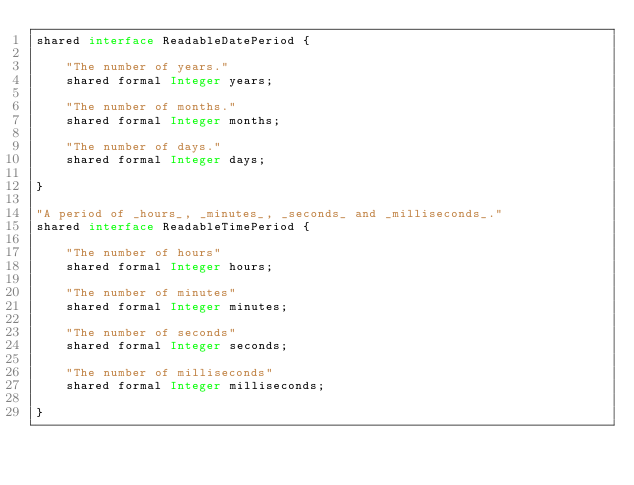<code> <loc_0><loc_0><loc_500><loc_500><_Ceylon_>shared interface ReadableDatePeriod {

    "The number of years."
    shared formal Integer years;

    "The number of months."
    shared formal Integer months;

    "The number of days."
    shared formal Integer days;

}

"A period of _hours_, _minutes_, _seconds_ and _milliseconds_."
shared interface ReadableTimePeriod {

    "The number of hours"
    shared formal Integer hours;

    "The number of minutes"
    shared formal Integer minutes;

    "The number of seconds"
    shared formal Integer seconds;

    "The number of milliseconds"
    shared formal Integer milliseconds;

}</code> 